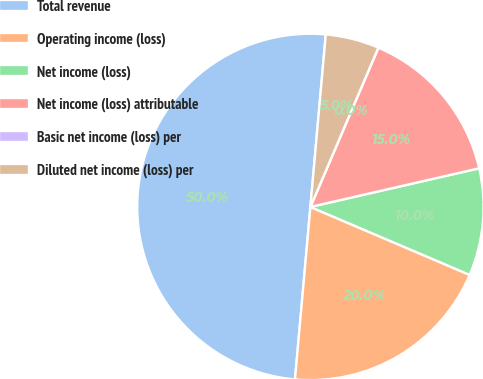<chart> <loc_0><loc_0><loc_500><loc_500><pie_chart><fcel>Total revenue<fcel>Operating income (loss)<fcel>Net income (loss)<fcel>Net income (loss) attributable<fcel>Basic net income (loss) per<fcel>Diluted net income (loss) per<nl><fcel>50.0%<fcel>20.0%<fcel>10.0%<fcel>15.0%<fcel>0.0%<fcel>5.0%<nl></chart> 